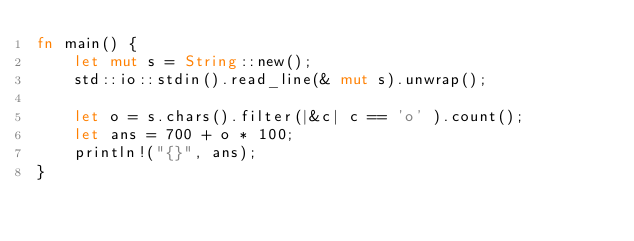Convert code to text. <code><loc_0><loc_0><loc_500><loc_500><_Rust_>fn main() {
    let mut s = String::new();
    std::io::stdin().read_line(& mut s).unwrap();
    
    let o = s.chars().filter(|&c| c == 'o' ).count();
    let ans = 700 + o * 100;
    println!("{}", ans);
}</code> 